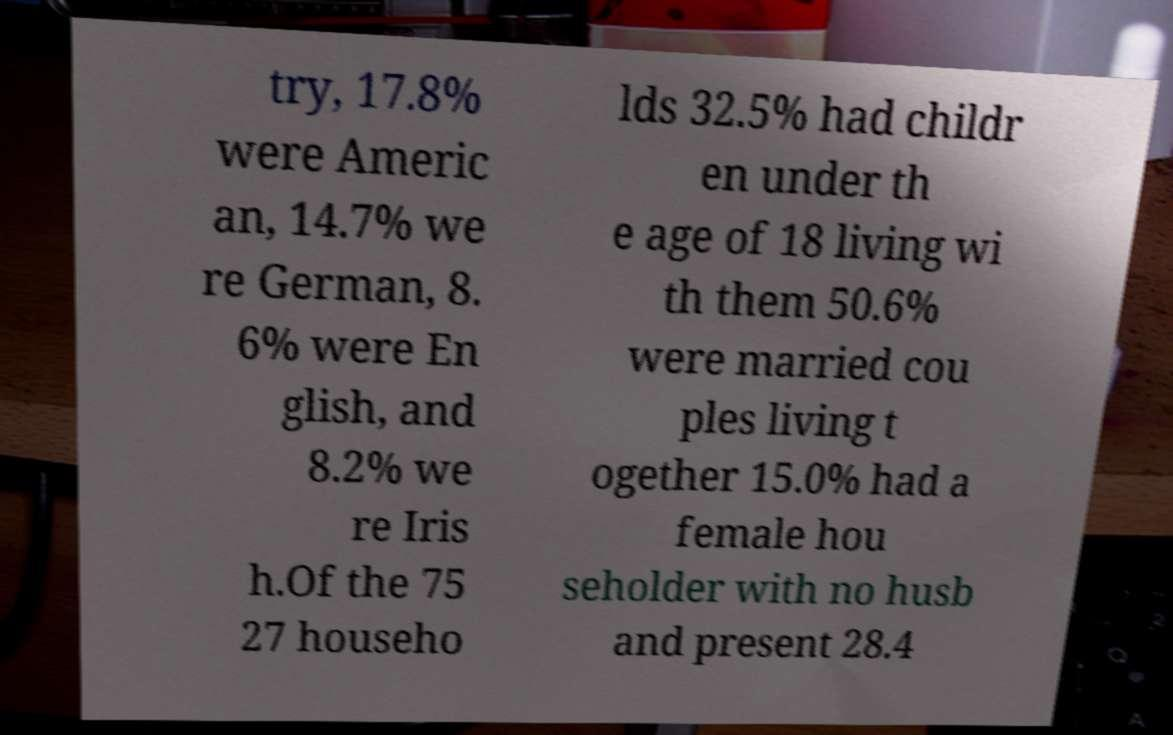Can you accurately transcribe the text from the provided image for me? try, 17.8% were Americ an, 14.7% we re German, 8. 6% were En glish, and 8.2% we re Iris h.Of the 75 27 househo lds 32.5% had childr en under th e age of 18 living wi th them 50.6% were married cou ples living t ogether 15.0% had a female hou seholder with no husb and present 28.4 